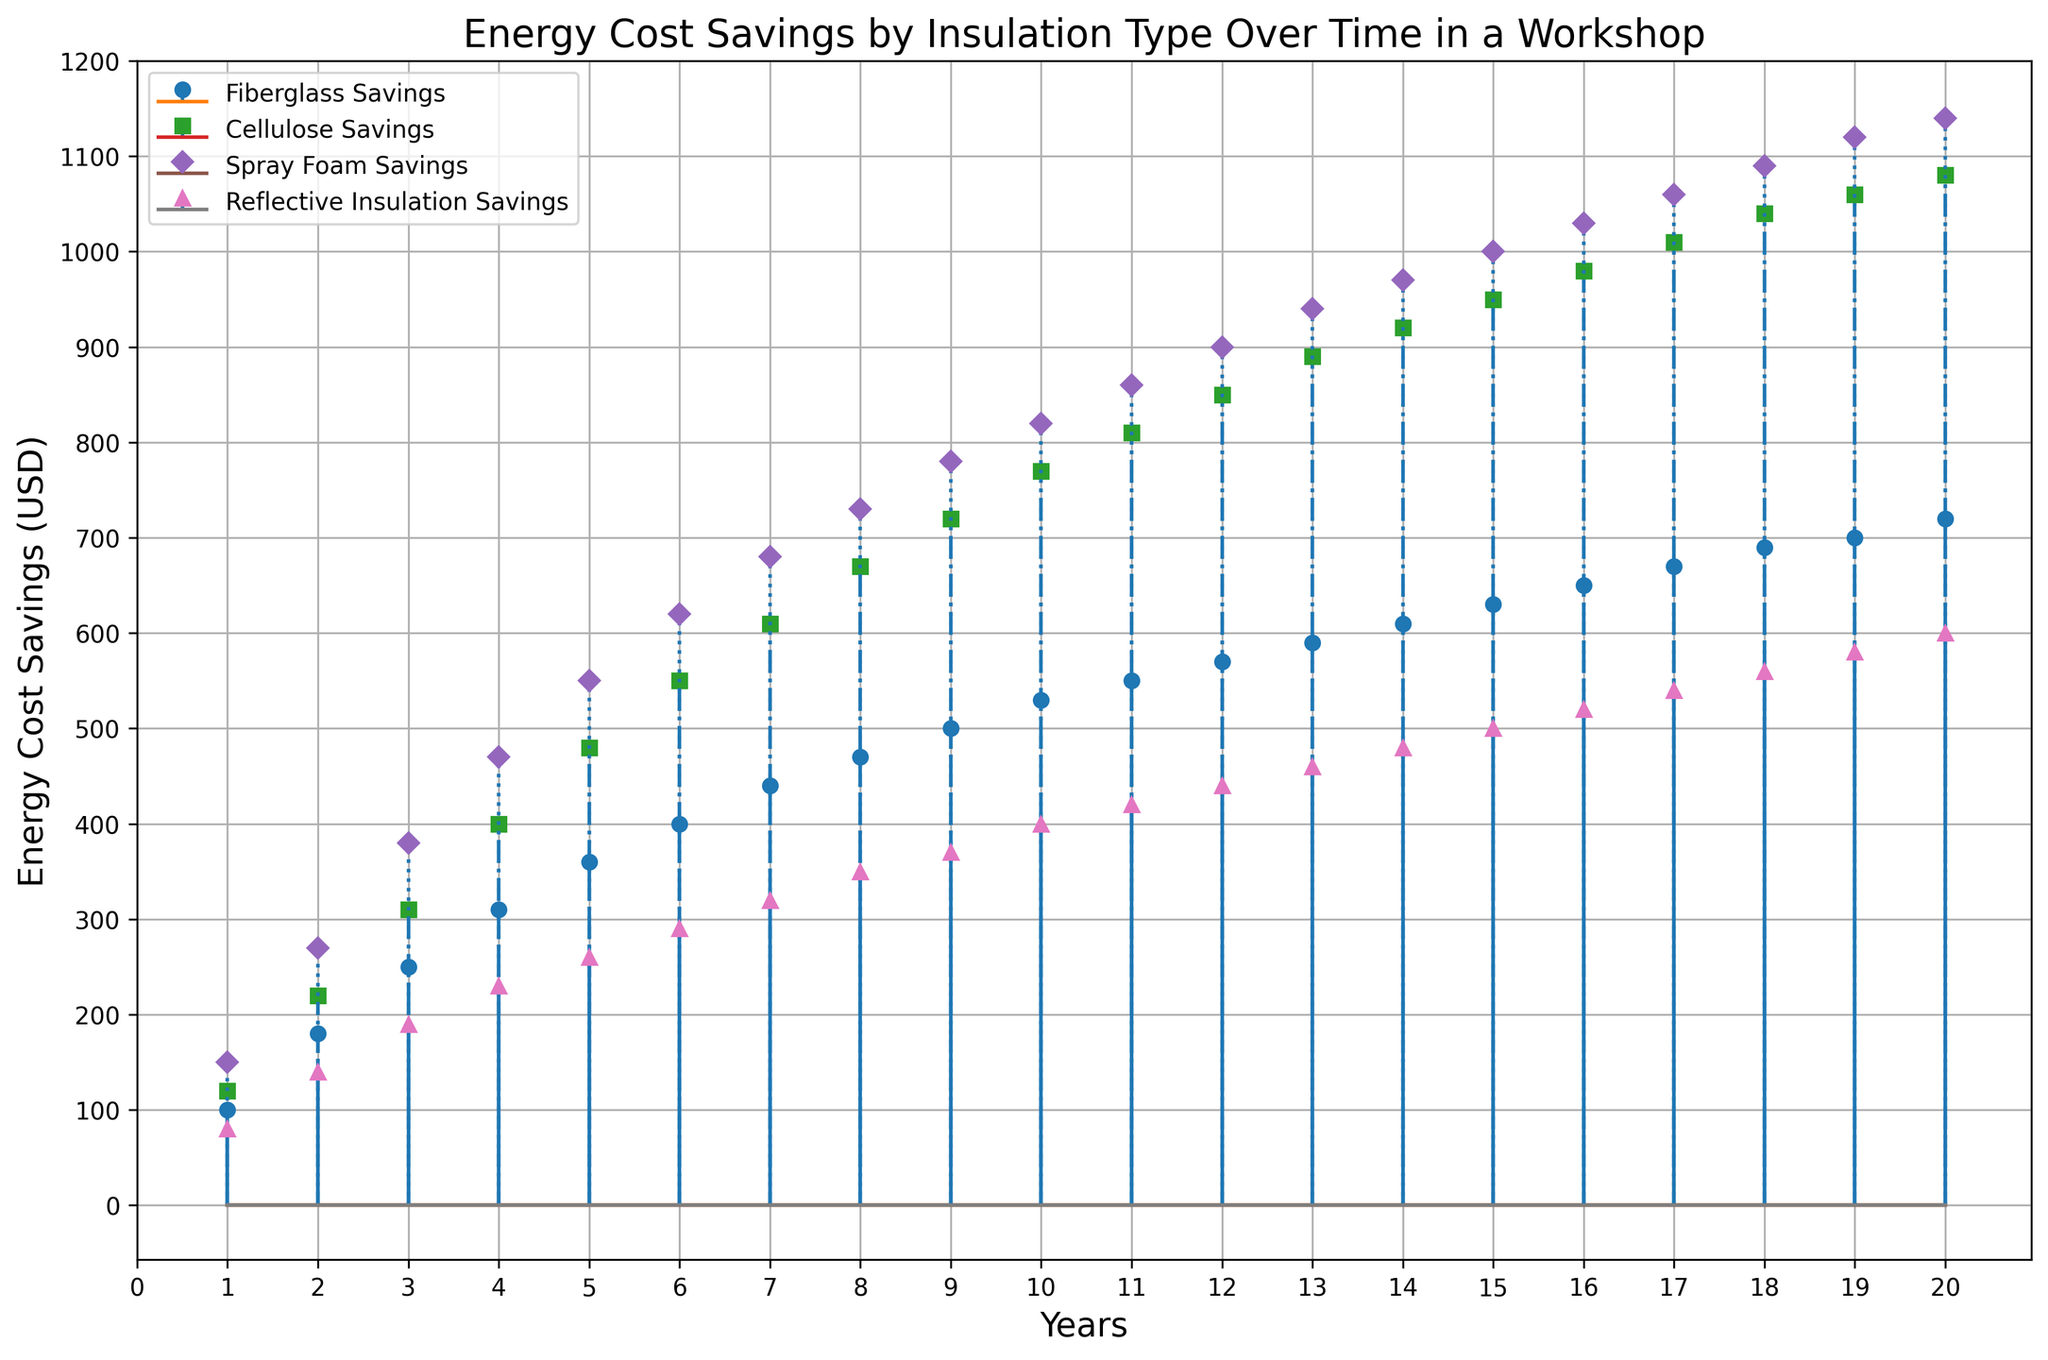What's the highest energy cost savings achieved by Reflective Insulation? By examining the stem plot for Reflective Insulation Savings over the years, note the highest point reached on the plot.
Answer: 600 Which insulation type provided the highest savings in the first year? Look at the energy cost savings for each insulation type in the first year and identify the highest value.
Answer: Spray Foam How do the energy savings in year 10 compare between Fiberglass and Cellulose insulation? Find the values for Fiberglass and Cellulose savings in year 10 and compare the two. Fiberglass savings are 530, while Cellulose savings are 770.
Answer: Cellulose savings are higher than Fiberglass savings What is the range of energy cost savings from Fiberglass insulation over the 20 years? Calculate the difference between the maximum and minimum savings for Fiberglass over the 20 years. The maximum savings are 720, and the minimum savings are 100. 720 - 100 gives 620.
Answer: 620 By how much did Spray Foam insulation savings increase from year 2 to year 3? Subtract the Spray Foam savings in year 2 from those in year 3, indicating an increase of 380 - 270 = 110.
Answer: 110 What is the average energy savings of Cellulose insulation over the first 5 years? Sum the Cellulose savings for the first 5 years (120 + 220 + 310 + 400 + 480) and divide by 5 to find the average. This simplifies to 1530 / 5 = 306.
Answer: 306 In which year did Fiberglass insulation cross the 400 USD savings mark? Identify the year on the stem plot where the Fiberglass savings first exceed 400 USD. This happens in year 6.
Answer: Year 6 How do Reflective Insulation savings progress compared to Spray Foam over 20 years? Compare the slope and values of the respective savings lines over the years. Reflective Insulation has a slower increase compared to Spray Foam.
Answer: Spray Foam increases faster How many years did Spray Foam insulation take to reach 1000 USD savings? Identify the year on the stem plot when Spray Foam savings first reach or exceed 1000 USD, which happens in year 15.
Answer: 15 years Are the energy savings trends for all insulation types linear or nonlinear? Observe the shape of the stem plot lines to determine if the trend lines are straight (linear) or curved (nonlinear).
Answer: Linear 